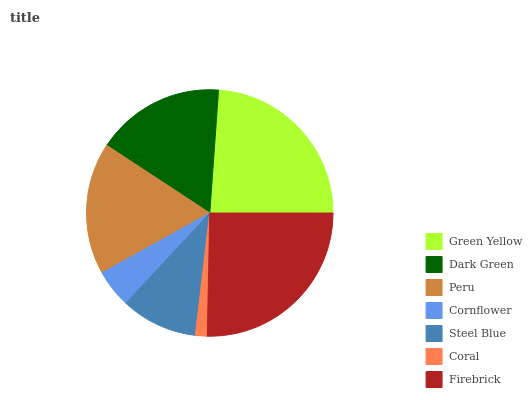Is Coral the minimum?
Answer yes or no. Yes. Is Firebrick the maximum?
Answer yes or no. Yes. Is Dark Green the minimum?
Answer yes or no. No. Is Dark Green the maximum?
Answer yes or no. No. Is Green Yellow greater than Dark Green?
Answer yes or no. Yes. Is Dark Green less than Green Yellow?
Answer yes or no. Yes. Is Dark Green greater than Green Yellow?
Answer yes or no. No. Is Green Yellow less than Dark Green?
Answer yes or no. No. Is Dark Green the high median?
Answer yes or no. Yes. Is Dark Green the low median?
Answer yes or no. Yes. Is Firebrick the high median?
Answer yes or no. No. Is Steel Blue the low median?
Answer yes or no. No. 